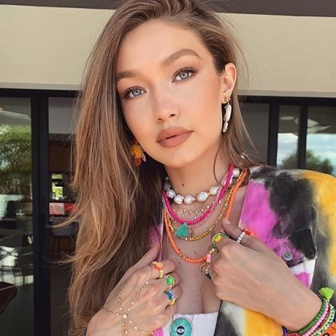Can you imagine a daily routine for the woman depicted in the image? Starting her day with morning yoga in the park, the woman then enjoys a colorful and nutritious breakfast of fresh fruits and smoothies. She spends her day working as an artist, creating vibrant paintings inspired by the colors she adorns in her attire. By afternoon, she indulges in a casual stroll through the urban streets, sipping coffee at a cozy local cafe. The evening sees her engaging in community activities, perhaps a music jam session or an art workshop, blending her bohemian spirit with the bustling urban life around her.  What might the woman be thinking at this moment? She might be contemplating her journey, reflecting on her experiences and the vibrant connections she has made along the way. The moment captures her in a state of reflection and gratitude, feeling a sense of contentment and excitement for the adventures yet to come. 